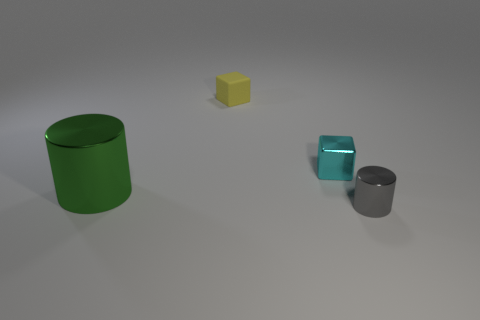Does the block that is to the left of the small cyan shiny block have the same color as the metal cube?
Make the answer very short. No. Is the number of green cylinders that are to the left of the big green thing greater than the number of yellow matte objects?
Ensure brevity in your answer.  No. Are there any other things of the same color as the rubber block?
Ensure brevity in your answer.  No. There is a tiny shiny object to the left of the cylinder that is to the right of the big metal object; what shape is it?
Ensure brevity in your answer.  Cube. Are there more small gray cylinders than large blue blocks?
Your response must be concise. Yes. How many things are in front of the rubber object and to the right of the large green metallic object?
Ensure brevity in your answer.  2. What number of small metallic cylinders are in front of the small shiny object behind the tiny gray cylinder?
Your response must be concise. 1. What number of things are shiny objects left of the small cylinder or metal things that are on the left side of the tiny cyan shiny cube?
Offer a terse response. 2. There is another tiny cyan thing that is the same shape as the rubber thing; what is it made of?
Give a very brief answer. Metal. What number of things are either cylinders that are on the left side of the small gray shiny thing or tiny yellow matte blocks?
Provide a succinct answer. 2. 